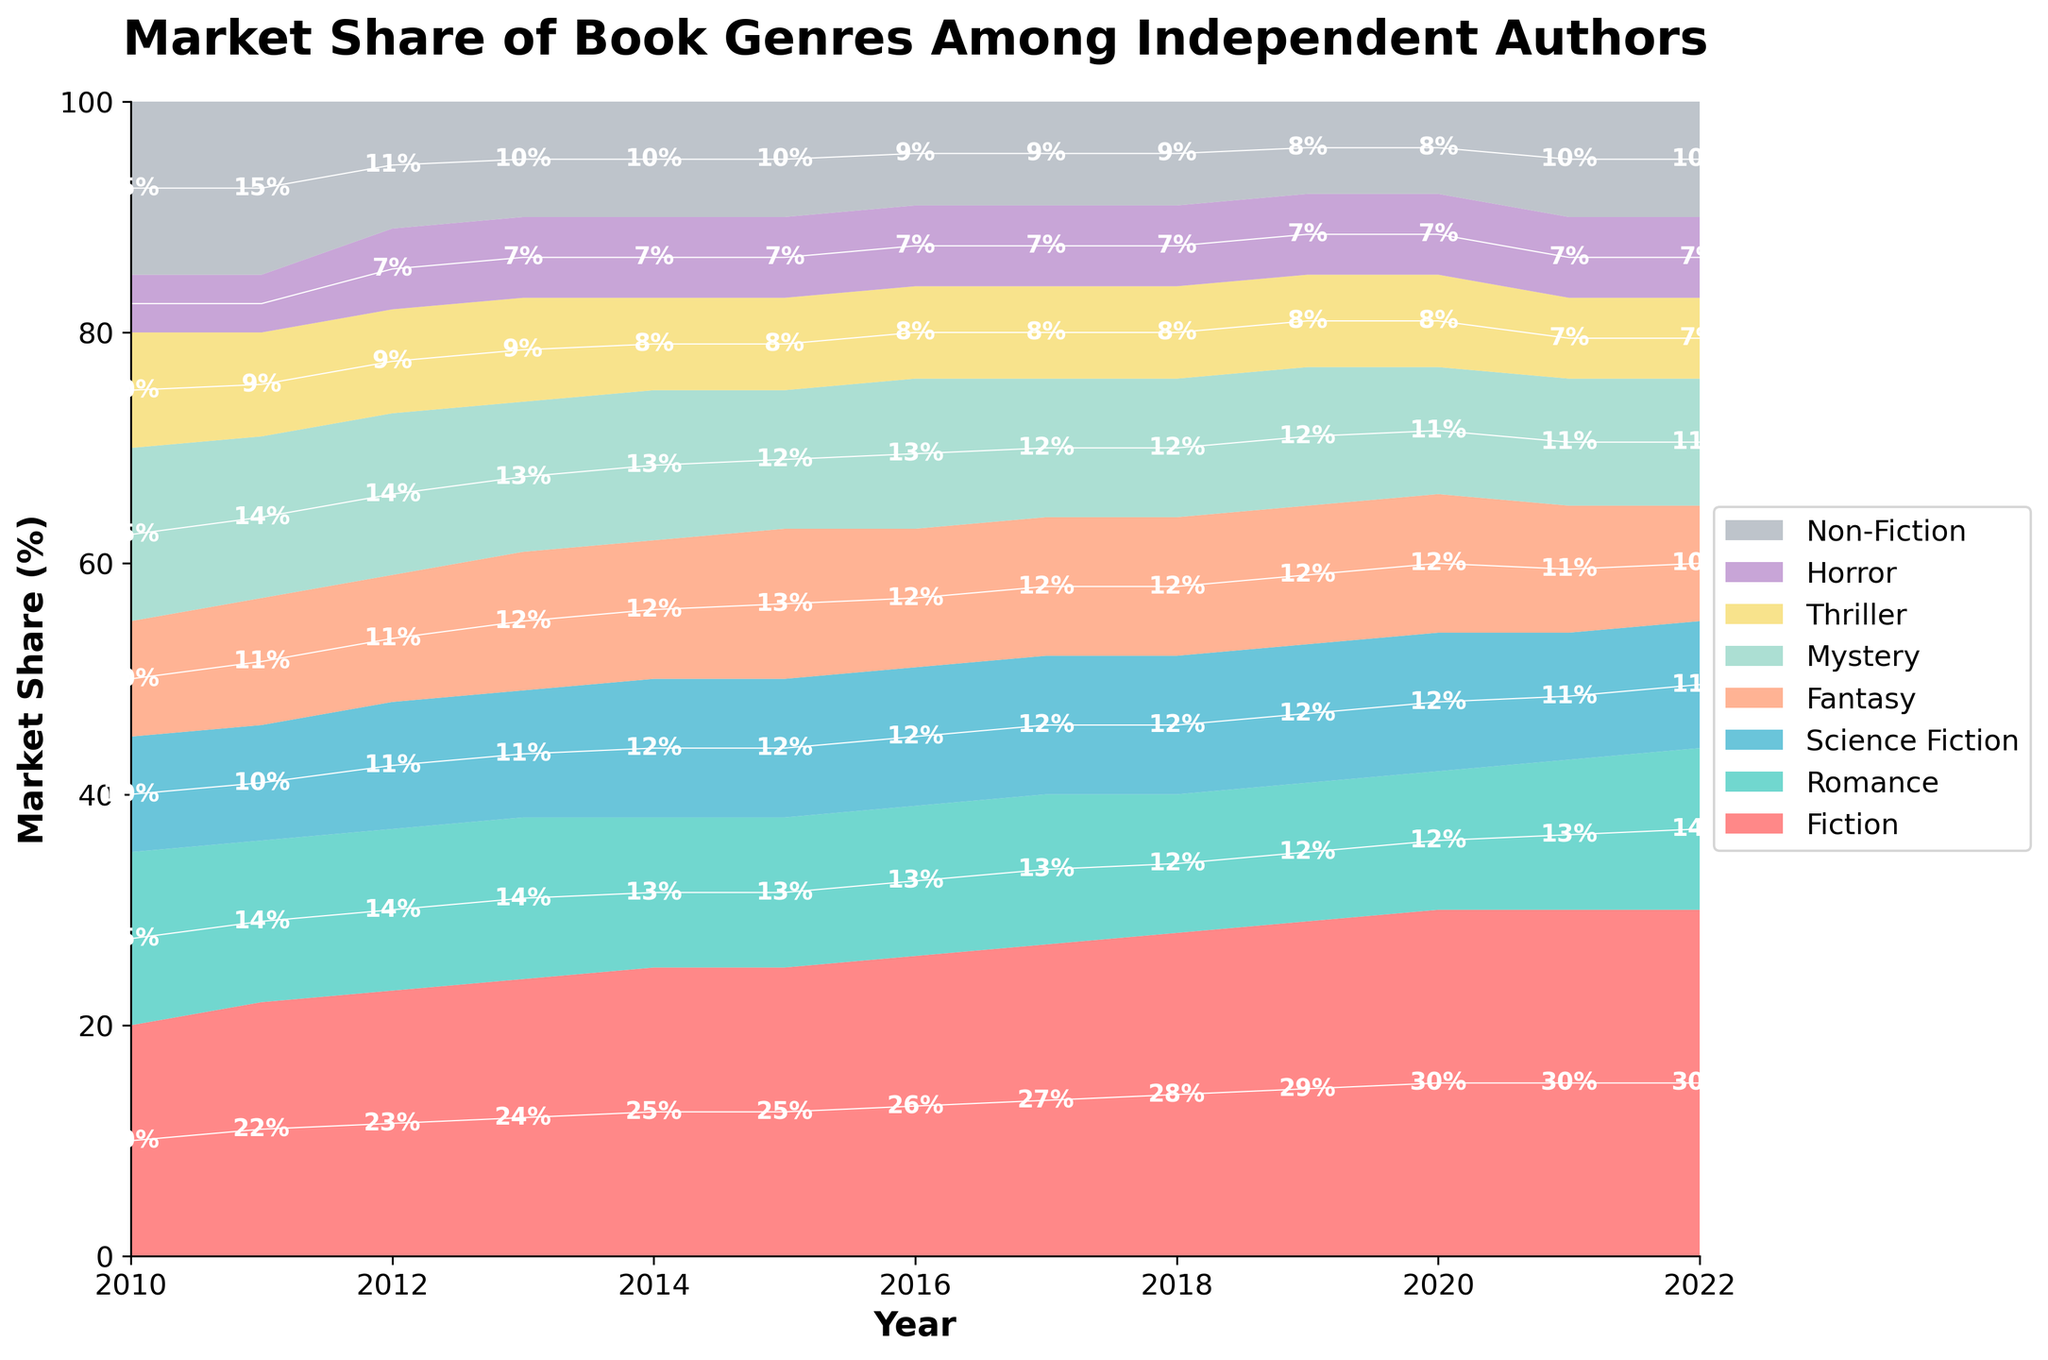Which book genre has the highest market share in 2022? To find the genre with the highest market share in 2022, we look for the topmost section in the stacked area chart for that year. The chart shows the top section’s color and label, which corresponds to 30% for Fiction.
Answer: Fiction How did the market share of Non-Fiction change from 2010 to 2012? We need to identify the Non-Fiction section's share in 2010 and 2012. In 2010, it was 15%, and in 2012, it dropped to 11%. Taking the difference, 15% - 11% = 4%, Non-Fiction’s market share decreased by 4 percentage points.
Answer: Decreased by 4 percentage points Which year did Romance genre experience its minimum market share? By identifying each segment corresponding to Romance over the years, we find that the minimum market share occurred in 2018 and 2019 at 12%.
Answer: 2018 and 2019 Which two genres had equal market share in 2016? In 2016, examining the stacked sections, both Science Fiction and Fantasy are shown to have had an equal market share of 12%.
Answer: Science Fiction and Fantasy What is the total market share of Fiction and Romance combined in 2014? The chart shows Fiction at 25% and Romance at 13% in 2014. To find the total, add them up: 25% + 13% = 38%.
Answer: 38% Which genre showed a continuous market share increase between 2010 and 2020? By examining each genre's trend, Fiction consistently increased its share, from 20% in 2010 to 30% in 2020, indicating a continuous upward trend.
Answer: Fiction How does the market share of Horror in 2020 compare to its share in 2010? The chart shows that the market share of Horror was 5% in 2010 and increased to 7% in 2020. Hence, it increased.
Answer: Increased Which year did Mystery and Thriller together exceed 20% market share for the first time? Trace the combined share of Mystery and Thriller each year until it exceeds 20%. In 2010, their combined share was 15% + 10% = 25%. This exceeds 20% in 2010 itself.
Answer: 2010 What is the difference in market share between the highest and lowest genres in 2015? In 2015, Fiction has the highest share at 25%, and Horror has the lowest at 7%. Difference is 25% - 7% = 18%.
Answer: 18% Which genre shows the least variation in market share over the years, and what is its general trend? Comparing the changes in market share for each genre, Non-Fiction varied from 15% to 8% over the years, showing the least variation. Its general trend is a decrease.
Answer: Non-Fiction, decreasing 